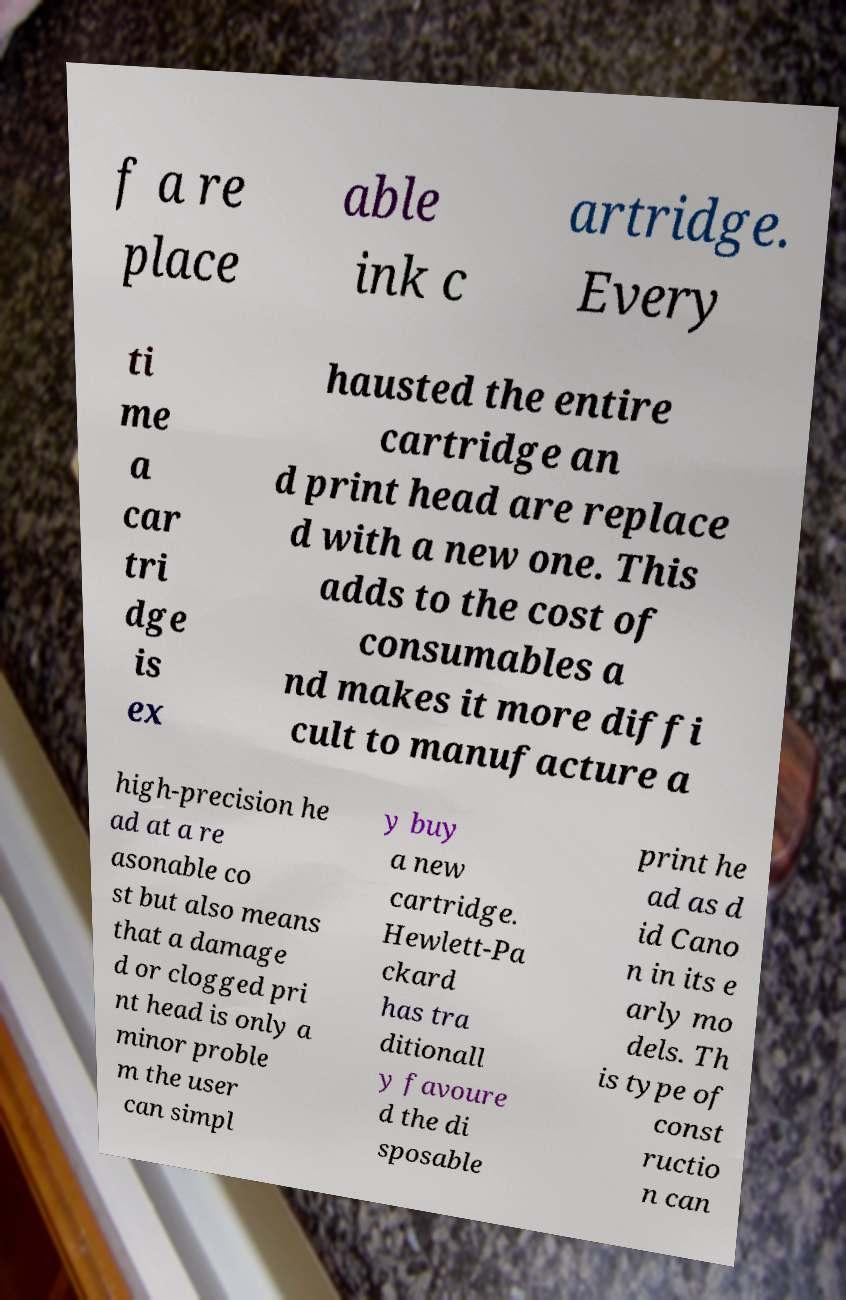Please identify and transcribe the text found in this image. f a re place able ink c artridge. Every ti me a car tri dge is ex hausted the entire cartridge an d print head are replace d with a new one. This adds to the cost of consumables a nd makes it more diffi cult to manufacture a high-precision he ad at a re asonable co st but also means that a damage d or clogged pri nt head is only a minor proble m the user can simpl y buy a new cartridge. Hewlett-Pa ckard has tra ditionall y favoure d the di sposable print he ad as d id Cano n in its e arly mo dels. Th is type of const ructio n can 